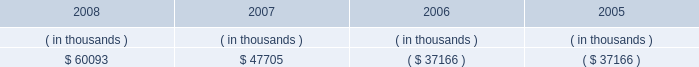Entergy new orleans , inc .
Management's financial discussion and analysis ( 1 ) includes approximately $ 30 million annually for maintenance capital , which is planned spending on routine capital projects that are necessary to support reliability of service , equipment or systems and to support normal customer growth .
( 2 ) purchase obligations represent the minimum purchase obligation or cancellation charge for contractual obligations to purchase goods or services .
For entergy new orleans , almost all of the total consists of unconditional fuel and purchased power obligations , including its obligations under the unit power sales agreement , which is discussed in note 8 to the financial statements .
In addition to the contractual obligations given above , entergy new orleans expects to make payments of approximately $ 113 million for the years 2009-2011 related to hurricane katrina and hurricane gustav restoration work and its gas rebuild project , of which $ 32 million is expected to be incurred in 2009 .
Also , entergy new orleans expects to contribute $ 1.7 million to its pension plan and $ 5.9 million to its other postretirement plans in 2009 .
Guidance pursuant to the pension protection act of 2006 rules , effective for the 2008 plan year and beyond , may affect the level of entergy new orleans' pension contributions in the future .
Also in addition to the contractual obligations , entergy new orleans has $ 26.1 million of unrecognized tax benefits and interest for which the timing of payments beyond 12 months cannot be reasonably estimated due to uncertainties in the timing of effective settlement of tax positions .
See note 3 to the financial statements for additional information regarding unrecognized tax benefits .
The planned capital investment estimate for entergy new orleans reflects capital required to support existing business .
The estimated capital expenditures are subject to periodic review and modification and may vary based on the ongoing effects of regulatory constraints , environmental compliance , market volatility , economic trends , and the ability to access capital .
Management provides more information on long-term debt and preferred stock maturities in notes 5 and 6 and to the financial statements .
Sources of capital entergy new orleans' sources to meet its capital requirements include : internally generated funds ; cash on hand ; and debt and preferred stock issuances .
Entergy new orleans' receivables from or ( payables to ) the money pool were as follows as of december 31 for each of the following years: .
See note 4 to the financial statements for a description of the money pool .
As discussed above in "bankruptcy proceedings" , entergy new orleans issued notes due in three years in satisfaction of its affiliate prepetition accounts payable , including its indebtedness to the entergy system money pool of $ 37.2 million .
Entergy new orleans has obtained short-term borrowing authorization from the ferc under which it may borrow through march 2010 , up to the aggregate amount , at any one time outstanding , of $ 100 million .
See note 4 to the financial statements for further discussion of entergy new orleans' short-term borrowing limits .
The long- term securities issuances of entergy new orleans are limited to amounts authorized by the city council , and the current authorization extends through august 2010. .
What is the percent change in net receivables from the money pool between 2007 and 2008? 
Computations: ((60093 - 47705) / 47705)
Answer: 0.25968. 